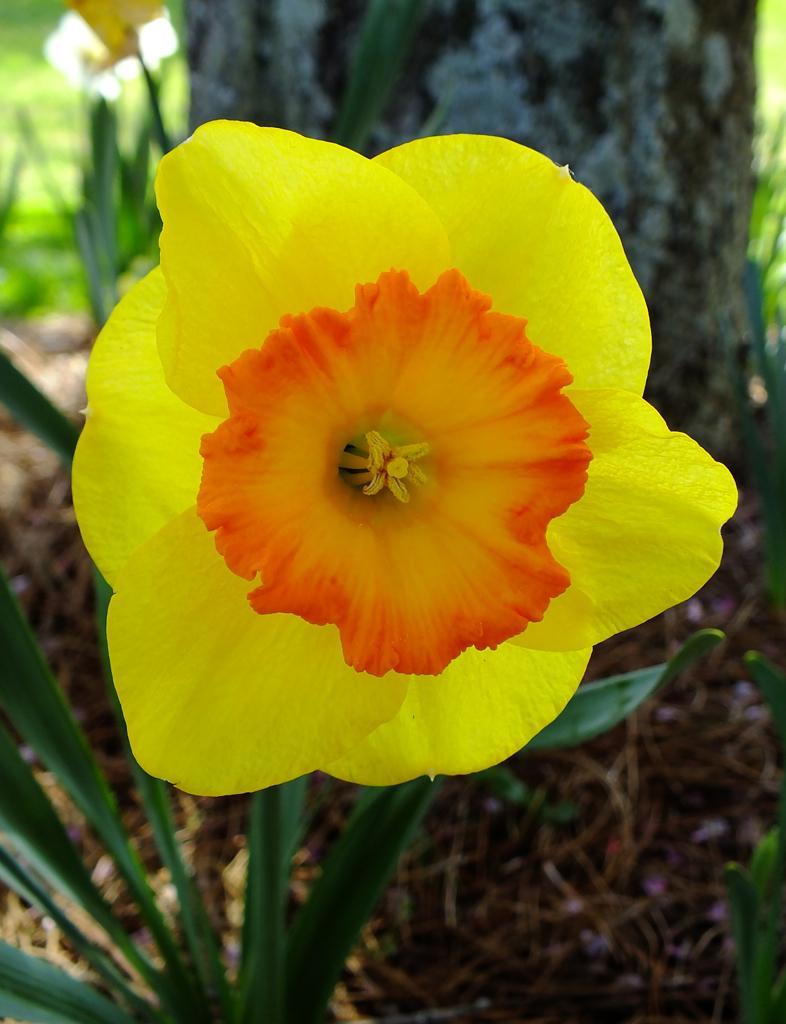Please provide a concise description of this image. This image is taken outdoors. In the background there is a tree and there is a ground with grass on it. In the middle of the image there is a plant with green leaves and a flower which is yellow and orange in colour. 